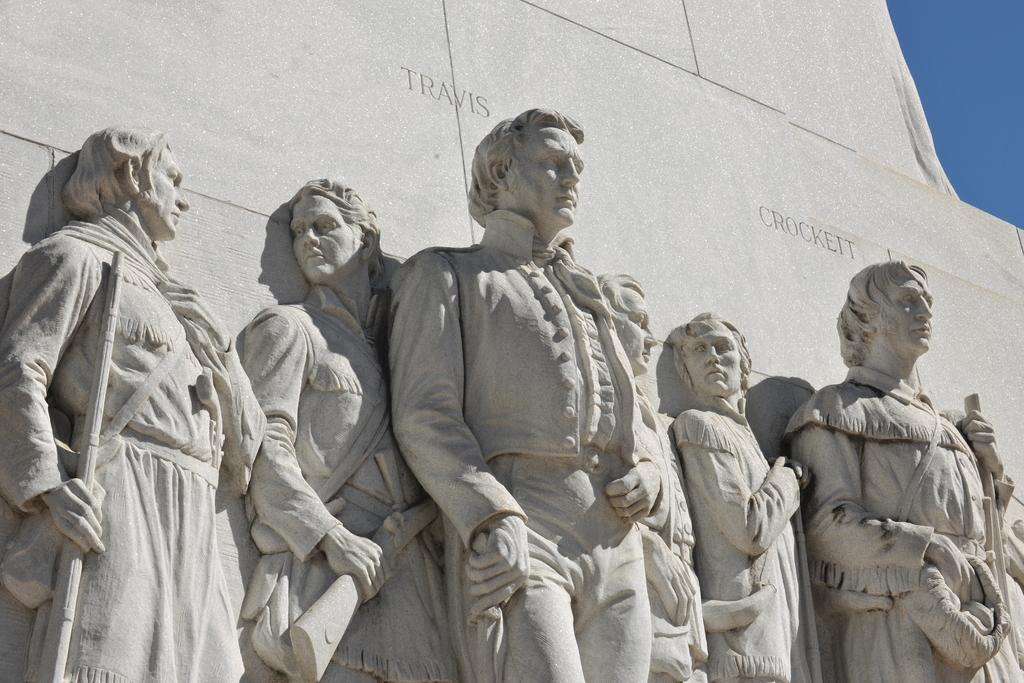What objects are present in the image? There are statues in the image. What architectural feature is visible at the top of the image? There is a wall visible at the top of the image. What part of the natural environment is visible in the image? The sky is visible at the top of the image. What type of bag can be seen hanging from the statues in the image? There is no bag present in the image; it only features statues, a wall, and the sky. Can you tell me how many owls are sitting on the statues in the image? There are no owls present in the image; it only features statues, a wall, and the sky. 